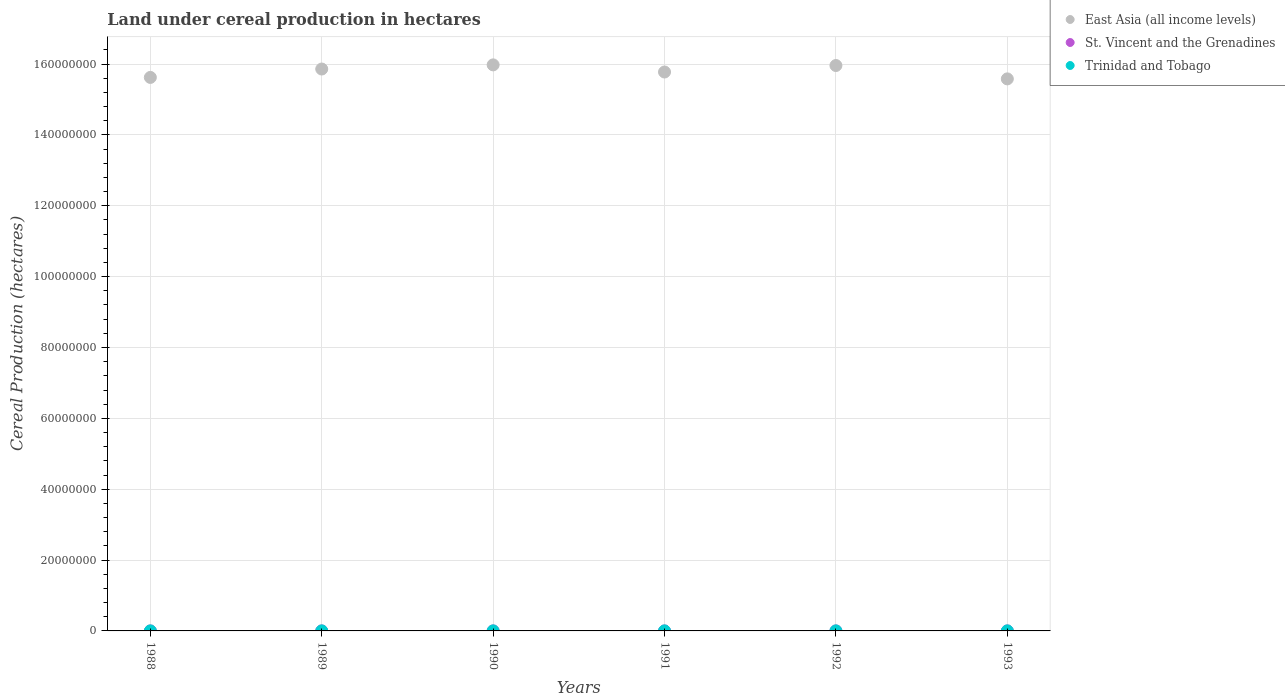Is the number of dotlines equal to the number of legend labels?
Make the answer very short. Yes. What is the land under cereal production in East Asia (all income levels) in 1991?
Offer a very short reply. 1.58e+08. Across all years, what is the maximum land under cereal production in East Asia (all income levels)?
Ensure brevity in your answer.  1.60e+08. Across all years, what is the minimum land under cereal production in St. Vincent and the Grenadines?
Your response must be concise. 505. In which year was the land under cereal production in East Asia (all income levels) minimum?
Provide a short and direct response. 1993. What is the total land under cereal production in St. Vincent and the Grenadines in the graph?
Offer a terse response. 3898. What is the difference between the land under cereal production in Trinidad and Tobago in 1991 and that in 1993?
Offer a terse response. -545. What is the difference between the land under cereal production in St. Vincent and the Grenadines in 1993 and the land under cereal production in East Asia (all income levels) in 1989?
Keep it short and to the point. -1.59e+08. What is the average land under cereal production in East Asia (all income levels) per year?
Provide a succinct answer. 1.58e+08. In the year 1993, what is the difference between the land under cereal production in Trinidad and Tobago and land under cereal production in St. Vincent and the Grenadines?
Ensure brevity in your answer.  5739. What is the ratio of the land under cereal production in Trinidad and Tobago in 1989 to that in 1992?
Give a very brief answer. 0.82. Is the land under cereal production in East Asia (all income levels) in 1988 less than that in 1993?
Offer a very short reply. No. Is the difference between the land under cereal production in Trinidad and Tobago in 1989 and 1992 greater than the difference between the land under cereal production in St. Vincent and the Grenadines in 1989 and 1992?
Provide a succinct answer. No. What is the difference between the highest and the second highest land under cereal production in East Asia (all income levels)?
Your response must be concise. 1.80e+05. What is the difference between the highest and the lowest land under cereal production in Trinidad and Tobago?
Your answer should be compact. 3250. Is the land under cereal production in St. Vincent and the Grenadines strictly greater than the land under cereal production in Trinidad and Tobago over the years?
Offer a very short reply. No. Is the land under cereal production in St. Vincent and the Grenadines strictly less than the land under cereal production in East Asia (all income levels) over the years?
Provide a short and direct response. Yes. How many years are there in the graph?
Ensure brevity in your answer.  6. Are the values on the major ticks of Y-axis written in scientific E-notation?
Keep it short and to the point. No. Does the graph contain grids?
Give a very brief answer. Yes. Where does the legend appear in the graph?
Give a very brief answer. Top right. How many legend labels are there?
Give a very brief answer. 3. What is the title of the graph?
Ensure brevity in your answer.  Land under cereal production in hectares. Does "Vietnam" appear as one of the legend labels in the graph?
Provide a succinct answer. No. What is the label or title of the X-axis?
Keep it short and to the point. Years. What is the label or title of the Y-axis?
Keep it short and to the point. Cereal Production (hectares). What is the Cereal Production (hectares) in East Asia (all income levels) in 1988?
Your response must be concise. 1.56e+08. What is the Cereal Production (hectares) of St. Vincent and the Grenadines in 1988?
Make the answer very short. 505. What is the Cereal Production (hectares) of Trinidad and Tobago in 1988?
Your answer should be very brief. 3850. What is the Cereal Production (hectares) of East Asia (all income levels) in 1989?
Your response must be concise. 1.59e+08. What is the Cereal Production (hectares) in St. Vincent and the Grenadines in 1989?
Your answer should be very brief. 605. What is the Cereal Production (hectares) of Trinidad and Tobago in 1989?
Ensure brevity in your answer.  5850. What is the Cereal Production (hectares) of East Asia (all income levels) in 1990?
Offer a very short reply. 1.60e+08. What is the Cereal Production (hectares) in St. Vincent and the Grenadines in 1990?
Give a very brief answer. 704. What is the Cereal Production (hectares) in Trinidad and Tobago in 1990?
Give a very brief answer. 5085. What is the Cereal Production (hectares) in East Asia (all income levels) in 1991?
Your response must be concise. 1.58e+08. What is the Cereal Production (hectares) in St. Vincent and the Grenadines in 1991?
Your answer should be very brief. 600. What is the Cereal Production (hectares) of Trinidad and Tobago in 1991?
Provide a succinct answer. 5955. What is the Cereal Production (hectares) of East Asia (all income levels) in 1992?
Offer a terse response. 1.60e+08. What is the Cereal Production (hectares) of St. Vincent and the Grenadines in 1992?
Provide a short and direct response. 723. What is the Cereal Production (hectares) in Trinidad and Tobago in 1992?
Offer a very short reply. 7100. What is the Cereal Production (hectares) of East Asia (all income levels) in 1993?
Your answer should be very brief. 1.56e+08. What is the Cereal Production (hectares) in St. Vincent and the Grenadines in 1993?
Your response must be concise. 761. What is the Cereal Production (hectares) of Trinidad and Tobago in 1993?
Offer a terse response. 6500. Across all years, what is the maximum Cereal Production (hectares) of East Asia (all income levels)?
Make the answer very short. 1.60e+08. Across all years, what is the maximum Cereal Production (hectares) in St. Vincent and the Grenadines?
Make the answer very short. 761. Across all years, what is the maximum Cereal Production (hectares) of Trinidad and Tobago?
Offer a terse response. 7100. Across all years, what is the minimum Cereal Production (hectares) of East Asia (all income levels)?
Your answer should be compact. 1.56e+08. Across all years, what is the minimum Cereal Production (hectares) in St. Vincent and the Grenadines?
Give a very brief answer. 505. Across all years, what is the minimum Cereal Production (hectares) in Trinidad and Tobago?
Give a very brief answer. 3850. What is the total Cereal Production (hectares) in East Asia (all income levels) in the graph?
Make the answer very short. 9.48e+08. What is the total Cereal Production (hectares) in St. Vincent and the Grenadines in the graph?
Offer a very short reply. 3898. What is the total Cereal Production (hectares) of Trinidad and Tobago in the graph?
Provide a succinct answer. 3.43e+04. What is the difference between the Cereal Production (hectares) in East Asia (all income levels) in 1988 and that in 1989?
Make the answer very short. -2.37e+06. What is the difference between the Cereal Production (hectares) of St. Vincent and the Grenadines in 1988 and that in 1989?
Make the answer very short. -100. What is the difference between the Cereal Production (hectares) of Trinidad and Tobago in 1988 and that in 1989?
Keep it short and to the point. -2000. What is the difference between the Cereal Production (hectares) of East Asia (all income levels) in 1988 and that in 1990?
Offer a very short reply. -3.54e+06. What is the difference between the Cereal Production (hectares) of St. Vincent and the Grenadines in 1988 and that in 1990?
Keep it short and to the point. -199. What is the difference between the Cereal Production (hectares) of Trinidad and Tobago in 1988 and that in 1990?
Give a very brief answer. -1235. What is the difference between the Cereal Production (hectares) in East Asia (all income levels) in 1988 and that in 1991?
Give a very brief answer. -1.53e+06. What is the difference between the Cereal Production (hectares) in St. Vincent and the Grenadines in 1988 and that in 1991?
Your response must be concise. -95. What is the difference between the Cereal Production (hectares) in Trinidad and Tobago in 1988 and that in 1991?
Keep it short and to the point. -2105. What is the difference between the Cereal Production (hectares) of East Asia (all income levels) in 1988 and that in 1992?
Make the answer very short. -3.36e+06. What is the difference between the Cereal Production (hectares) in St. Vincent and the Grenadines in 1988 and that in 1992?
Your answer should be very brief. -218. What is the difference between the Cereal Production (hectares) of Trinidad and Tobago in 1988 and that in 1992?
Keep it short and to the point. -3250. What is the difference between the Cereal Production (hectares) in East Asia (all income levels) in 1988 and that in 1993?
Give a very brief answer. 4.13e+05. What is the difference between the Cereal Production (hectares) in St. Vincent and the Grenadines in 1988 and that in 1993?
Your answer should be very brief. -256. What is the difference between the Cereal Production (hectares) of Trinidad and Tobago in 1988 and that in 1993?
Give a very brief answer. -2650. What is the difference between the Cereal Production (hectares) in East Asia (all income levels) in 1989 and that in 1990?
Offer a very short reply. -1.17e+06. What is the difference between the Cereal Production (hectares) of St. Vincent and the Grenadines in 1989 and that in 1990?
Your answer should be very brief. -99. What is the difference between the Cereal Production (hectares) of Trinidad and Tobago in 1989 and that in 1990?
Offer a very short reply. 765. What is the difference between the Cereal Production (hectares) in East Asia (all income levels) in 1989 and that in 1991?
Your answer should be compact. 8.42e+05. What is the difference between the Cereal Production (hectares) of Trinidad and Tobago in 1989 and that in 1991?
Keep it short and to the point. -105. What is the difference between the Cereal Production (hectares) of East Asia (all income levels) in 1989 and that in 1992?
Give a very brief answer. -9.92e+05. What is the difference between the Cereal Production (hectares) of St. Vincent and the Grenadines in 1989 and that in 1992?
Your response must be concise. -118. What is the difference between the Cereal Production (hectares) of Trinidad and Tobago in 1989 and that in 1992?
Your answer should be compact. -1250. What is the difference between the Cereal Production (hectares) of East Asia (all income levels) in 1989 and that in 1993?
Give a very brief answer. 2.78e+06. What is the difference between the Cereal Production (hectares) of St. Vincent and the Grenadines in 1989 and that in 1993?
Make the answer very short. -156. What is the difference between the Cereal Production (hectares) of Trinidad and Tobago in 1989 and that in 1993?
Keep it short and to the point. -650. What is the difference between the Cereal Production (hectares) of East Asia (all income levels) in 1990 and that in 1991?
Make the answer very short. 2.01e+06. What is the difference between the Cereal Production (hectares) of St. Vincent and the Grenadines in 1990 and that in 1991?
Provide a short and direct response. 104. What is the difference between the Cereal Production (hectares) of Trinidad and Tobago in 1990 and that in 1991?
Make the answer very short. -870. What is the difference between the Cereal Production (hectares) in East Asia (all income levels) in 1990 and that in 1992?
Ensure brevity in your answer.  1.80e+05. What is the difference between the Cereal Production (hectares) of St. Vincent and the Grenadines in 1990 and that in 1992?
Offer a terse response. -19. What is the difference between the Cereal Production (hectares) of Trinidad and Tobago in 1990 and that in 1992?
Offer a very short reply. -2015. What is the difference between the Cereal Production (hectares) of East Asia (all income levels) in 1990 and that in 1993?
Your answer should be very brief. 3.95e+06. What is the difference between the Cereal Production (hectares) of St. Vincent and the Grenadines in 1990 and that in 1993?
Give a very brief answer. -57. What is the difference between the Cereal Production (hectares) in Trinidad and Tobago in 1990 and that in 1993?
Ensure brevity in your answer.  -1415. What is the difference between the Cereal Production (hectares) of East Asia (all income levels) in 1991 and that in 1992?
Provide a short and direct response. -1.83e+06. What is the difference between the Cereal Production (hectares) in St. Vincent and the Grenadines in 1991 and that in 1992?
Your answer should be compact. -123. What is the difference between the Cereal Production (hectares) of Trinidad and Tobago in 1991 and that in 1992?
Provide a succinct answer. -1145. What is the difference between the Cereal Production (hectares) of East Asia (all income levels) in 1991 and that in 1993?
Your response must be concise. 1.94e+06. What is the difference between the Cereal Production (hectares) of St. Vincent and the Grenadines in 1991 and that in 1993?
Your answer should be compact. -161. What is the difference between the Cereal Production (hectares) of Trinidad and Tobago in 1991 and that in 1993?
Keep it short and to the point. -545. What is the difference between the Cereal Production (hectares) of East Asia (all income levels) in 1992 and that in 1993?
Provide a short and direct response. 3.77e+06. What is the difference between the Cereal Production (hectares) in St. Vincent and the Grenadines in 1992 and that in 1993?
Give a very brief answer. -38. What is the difference between the Cereal Production (hectares) of Trinidad and Tobago in 1992 and that in 1993?
Keep it short and to the point. 600. What is the difference between the Cereal Production (hectares) of East Asia (all income levels) in 1988 and the Cereal Production (hectares) of St. Vincent and the Grenadines in 1989?
Offer a terse response. 1.56e+08. What is the difference between the Cereal Production (hectares) in East Asia (all income levels) in 1988 and the Cereal Production (hectares) in Trinidad and Tobago in 1989?
Your response must be concise. 1.56e+08. What is the difference between the Cereal Production (hectares) in St. Vincent and the Grenadines in 1988 and the Cereal Production (hectares) in Trinidad and Tobago in 1989?
Offer a very short reply. -5345. What is the difference between the Cereal Production (hectares) in East Asia (all income levels) in 1988 and the Cereal Production (hectares) in St. Vincent and the Grenadines in 1990?
Your answer should be compact. 1.56e+08. What is the difference between the Cereal Production (hectares) of East Asia (all income levels) in 1988 and the Cereal Production (hectares) of Trinidad and Tobago in 1990?
Your answer should be very brief. 1.56e+08. What is the difference between the Cereal Production (hectares) in St. Vincent and the Grenadines in 1988 and the Cereal Production (hectares) in Trinidad and Tobago in 1990?
Your answer should be very brief. -4580. What is the difference between the Cereal Production (hectares) of East Asia (all income levels) in 1988 and the Cereal Production (hectares) of St. Vincent and the Grenadines in 1991?
Your answer should be very brief. 1.56e+08. What is the difference between the Cereal Production (hectares) in East Asia (all income levels) in 1988 and the Cereal Production (hectares) in Trinidad and Tobago in 1991?
Offer a very short reply. 1.56e+08. What is the difference between the Cereal Production (hectares) of St. Vincent and the Grenadines in 1988 and the Cereal Production (hectares) of Trinidad and Tobago in 1991?
Your answer should be compact. -5450. What is the difference between the Cereal Production (hectares) in East Asia (all income levels) in 1988 and the Cereal Production (hectares) in St. Vincent and the Grenadines in 1992?
Give a very brief answer. 1.56e+08. What is the difference between the Cereal Production (hectares) of East Asia (all income levels) in 1988 and the Cereal Production (hectares) of Trinidad and Tobago in 1992?
Keep it short and to the point. 1.56e+08. What is the difference between the Cereal Production (hectares) in St. Vincent and the Grenadines in 1988 and the Cereal Production (hectares) in Trinidad and Tobago in 1992?
Make the answer very short. -6595. What is the difference between the Cereal Production (hectares) in East Asia (all income levels) in 1988 and the Cereal Production (hectares) in St. Vincent and the Grenadines in 1993?
Offer a terse response. 1.56e+08. What is the difference between the Cereal Production (hectares) of East Asia (all income levels) in 1988 and the Cereal Production (hectares) of Trinidad and Tobago in 1993?
Make the answer very short. 1.56e+08. What is the difference between the Cereal Production (hectares) of St. Vincent and the Grenadines in 1988 and the Cereal Production (hectares) of Trinidad and Tobago in 1993?
Give a very brief answer. -5995. What is the difference between the Cereal Production (hectares) of East Asia (all income levels) in 1989 and the Cereal Production (hectares) of St. Vincent and the Grenadines in 1990?
Your answer should be very brief. 1.59e+08. What is the difference between the Cereal Production (hectares) of East Asia (all income levels) in 1989 and the Cereal Production (hectares) of Trinidad and Tobago in 1990?
Ensure brevity in your answer.  1.59e+08. What is the difference between the Cereal Production (hectares) in St. Vincent and the Grenadines in 1989 and the Cereal Production (hectares) in Trinidad and Tobago in 1990?
Give a very brief answer. -4480. What is the difference between the Cereal Production (hectares) of East Asia (all income levels) in 1989 and the Cereal Production (hectares) of St. Vincent and the Grenadines in 1991?
Your response must be concise. 1.59e+08. What is the difference between the Cereal Production (hectares) in East Asia (all income levels) in 1989 and the Cereal Production (hectares) in Trinidad and Tobago in 1991?
Provide a short and direct response. 1.59e+08. What is the difference between the Cereal Production (hectares) of St. Vincent and the Grenadines in 1989 and the Cereal Production (hectares) of Trinidad and Tobago in 1991?
Keep it short and to the point. -5350. What is the difference between the Cereal Production (hectares) in East Asia (all income levels) in 1989 and the Cereal Production (hectares) in St. Vincent and the Grenadines in 1992?
Provide a succinct answer. 1.59e+08. What is the difference between the Cereal Production (hectares) of East Asia (all income levels) in 1989 and the Cereal Production (hectares) of Trinidad and Tobago in 1992?
Provide a short and direct response. 1.59e+08. What is the difference between the Cereal Production (hectares) in St. Vincent and the Grenadines in 1989 and the Cereal Production (hectares) in Trinidad and Tobago in 1992?
Provide a succinct answer. -6495. What is the difference between the Cereal Production (hectares) in East Asia (all income levels) in 1989 and the Cereal Production (hectares) in St. Vincent and the Grenadines in 1993?
Offer a very short reply. 1.59e+08. What is the difference between the Cereal Production (hectares) in East Asia (all income levels) in 1989 and the Cereal Production (hectares) in Trinidad and Tobago in 1993?
Keep it short and to the point. 1.59e+08. What is the difference between the Cereal Production (hectares) of St. Vincent and the Grenadines in 1989 and the Cereal Production (hectares) of Trinidad and Tobago in 1993?
Give a very brief answer. -5895. What is the difference between the Cereal Production (hectares) of East Asia (all income levels) in 1990 and the Cereal Production (hectares) of St. Vincent and the Grenadines in 1991?
Offer a very short reply. 1.60e+08. What is the difference between the Cereal Production (hectares) in East Asia (all income levels) in 1990 and the Cereal Production (hectares) in Trinidad and Tobago in 1991?
Your answer should be compact. 1.60e+08. What is the difference between the Cereal Production (hectares) of St. Vincent and the Grenadines in 1990 and the Cereal Production (hectares) of Trinidad and Tobago in 1991?
Keep it short and to the point. -5251. What is the difference between the Cereal Production (hectares) in East Asia (all income levels) in 1990 and the Cereal Production (hectares) in St. Vincent and the Grenadines in 1992?
Keep it short and to the point. 1.60e+08. What is the difference between the Cereal Production (hectares) of East Asia (all income levels) in 1990 and the Cereal Production (hectares) of Trinidad and Tobago in 1992?
Provide a short and direct response. 1.60e+08. What is the difference between the Cereal Production (hectares) of St. Vincent and the Grenadines in 1990 and the Cereal Production (hectares) of Trinidad and Tobago in 1992?
Your answer should be compact. -6396. What is the difference between the Cereal Production (hectares) of East Asia (all income levels) in 1990 and the Cereal Production (hectares) of St. Vincent and the Grenadines in 1993?
Give a very brief answer. 1.60e+08. What is the difference between the Cereal Production (hectares) of East Asia (all income levels) in 1990 and the Cereal Production (hectares) of Trinidad and Tobago in 1993?
Offer a terse response. 1.60e+08. What is the difference between the Cereal Production (hectares) in St. Vincent and the Grenadines in 1990 and the Cereal Production (hectares) in Trinidad and Tobago in 1993?
Give a very brief answer. -5796. What is the difference between the Cereal Production (hectares) in East Asia (all income levels) in 1991 and the Cereal Production (hectares) in St. Vincent and the Grenadines in 1992?
Offer a terse response. 1.58e+08. What is the difference between the Cereal Production (hectares) in East Asia (all income levels) in 1991 and the Cereal Production (hectares) in Trinidad and Tobago in 1992?
Make the answer very short. 1.58e+08. What is the difference between the Cereal Production (hectares) in St. Vincent and the Grenadines in 1991 and the Cereal Production (hectares) in Trinidad and Tobago in 1992?
Provide a short and direct response. -6500. What is the difference between the Cereal Production (hectares) of East Asia (all income levels) in 1991 and the Cereal Production (hectares) of St. Vincent and the Grenadines in 1993?
Make the answer very short. 1.58e+08. What is the difference between the Cereal Production (hectares) of East Asia (all income levels) in 1991 and the Cereal Production (hectares) of Trinidad and Tobago in 1993?
Provide a short and direct response. 1.58e+08. What is the difference between the Cereal Production (hectares) of St. Vincent and the Grenadines in 1991 and the Cereal Production (hectares) of Trinidad and Tobago in 1993?
Your answer should be compact. -5900. What is the difference between the Cereal Production (hectares) of East Asia (all income levels) in 1992 and the Cereal Production (hectares) of St. Vincent and the Grenadines in 1993?
Offer a terse response. 1.60e+08. What is the difference between the Cereal Production (hectares) in East Asia (all income levels) in 1992 and the Cereal Production (hectares) in Trinidad and Tobago in 1993?
Make the answer very short. 1.60e+08. What is the difference between the Cereal Production (hectares) in St. Vincent and the Grenadines in 1992 and the Cereal Production (hectares) in Trinidad and Tobago in 1993?
Offer a very short reply. -5777. What is the average Cereal Production (hectares) of East Asia (all income levels) per year?
Your answer should be compact. 1.58e+08. What is the average Cereal Production (hectares) of St. Vincent and the Grenadines per year?
Make the answer very short. 649.67. What is the average Cereal Production (hectares) of Trinidad and Tobago per year?
Offer a terse response. 5723.33. In the year 1988, what is the difference between the Cereal Production (hectares) of East Asia (all income levels) and Cereal Production (hectares) of St. Vincent and the Grenadines?
Keep it short and to the point. 1.56e+08. In the year 1988, what is the difference between the Cereal Production (hectares) in East Asia (all income levels) and Cereal Production (hectares) in Trinidad and Tobago?
Provide a succinct answer. 1.56e+08. In the year 1988, what is the difference between the Cereal Production (hectares) of St. Vincent and the Grenadines and Cereal Production (hectares) of Trinidad and Tobago?
Your response must be concise. -3345. In the year 1989, what is the difference between the Cereal Production (hectares) in East Asia (all income levels) and Cereal Production (hectares) in St. Vincent and the Grenadines?
Provide a short and direct response. 1.59e+08. In the year 1989, what is the difference between the Cereal Production (hectares) of East Asia (all income levels) and Cereal Production (hectares) of Trinidad and Tobago?
Your answer should be compact. 1.59e+08. In the year 1989, what is the difference between the Cereal Production (hectares) in St. Vincent and the Grenadines and Cereal Production (hectares) in Trinidad and Tobago?
Give a very brief answer. -5245. In the year 1990, what is the difference between the Cereal Production (hectares) in East Asia (all income levels) and Cereal Production (hectares) in St. Vincent and the Grenadines?
Offer a terse response. 1.60e+08. In the year 1990, what is the difference between the Cereal Production (hectares) of East Asia (all income levels) and Cereal Production (hectares) of Trinidad and Tobago?
Your answer should be very brief. 1.60e+08. In the year 1990, what is the difference between the Cereal Production (hectares) of St. Vincent and the Grenadines and Cereal Production (hectares) of Trinidad and Tobago?
Your response must be concise. -4381. In the year 1991, what is the difference between the Cereal Production (hectares) in East Asia (all income levels) and Cereal Production (hectares) in St. Vincent and the Grenadines?
Your answer should be very brief. 1.58e+08. In the year 1991, what is the difference between the Cereal Production (hectares) of East Asia (all income levels) and Cereal Production (hectares) of Trinidad and Tobago?
Offer a terse response. 1.58e+08. In the year 1991, what is the difference between the Cereal Production (hectares) of St. Vincent and the Grenadines and Cereal Production (hectares) of Trinidad and Tobago?
Offer a terse response. -5355. In the year 1992, what is the difference between the Cereal Production (hectares) of East Asia (all income levels) and Cereal Production (hectares) of St. Vincent and the Grenadines?
Make the answer very short. 1.60e+08. In the year 1992, what is the difference between the Cereal Production (hectares) of East Asia (all income levels) and Cereal Production (hectares) of Trinidad and Tobago?
Provide a short and direct response. 1.60e+08. In the year 1992, what is the difference between the Cereal Production (hectares) of St. Vincent and the Grenadines and Cereal Production (hectares) of Trinidad and Tobago?
Keep it short and to the point. -6377. In the year 1993, what is the difference between the Cereal Production (hectares) of East Asia (all income levels) and Cereal Production (hectares) of St. Vincent and the Grenadines?
Keep it short and to the point. 1.56e+08. In the year 1993, what is the difference between the Cereal Production (hectares) of East Asia (all income levels) and Cereal Production (hectares) of Trinidad and Tobago?
Provide a short and direct response. 1.56e+08. In the year 1993, what is the difference between the Cereal Production (hectares) in St. Vincent and the Grenadines and Cereal Production (hectares) in Trinidad and Tobago?
Ensure brevity in your answer.  -5739. What is the ratio of the Cereal Production (hectares) of East Asia (all income levels) in 1988 to that in 1989?
Provide a short and direct response. 0.99. What is the ratio of the Cereal Production (hectares) of St. Vincent and the Grenadines in 1988 to that in 1989?
Give a very brief answer. 0.83. What is the ratio of the Cereal Production (hectares) in Trinidad and Tobago in 1988 to that in 1989?
Make the answer very short. 0.66. What is the ratio of the Cereal Production (hectares) in East Asia (all income levels) in 1988 to that in 1990?
Offer a very short reply. 0.98. What is the ratio of the Cereal Production (hectares) of St. Vincent and the Grenadines in 1988 to that in 1990?
Your answer should be very brief. 0.72. What is the ratio of the Cereal Production (hectares) of Trinidad and Tobago in 1988 to that in 1990?
Make the answer very short. 0.76. What is the ratio of the Cereal Production (hectares) in East Asia (all income levels) in 1988 to that in 1991?
Provide a short and direct response. 0.99. What is the ratio of the Cereal Production (hectares) of St. Vincent and the Grenadines in 1988 to that in 1991?
Make the answer very short. 0.84. What is the ratio of the Cereal Production (hectares) in Trinidad and Tobago in 1988 to that in 1991?
Your response must be concise. 0.65. What is the ratio of the Cereal Production (hectares) of East Asia (all income levels) in 1988 to that in 1992?
Keep it short and to the point. 0.98. What is the ratio of the Cereal Production (hectares) in St. Vincent and the Grenadines in 1988 to that in 1992?
Your answer should be compact. 0.7. What is the ratio of the Cereal Production (hectares) of Trinidad and Tobago in 1988 to that in 1992?
Give a very brief answer. 0.54. What is the ratio of the Cereal Production (hectares) of East Asia (all income levels) in 1988 to that in 1993?
Keep it short and to the point. 1. What is the ratio of the Cereal Production (hectares) of St. Vincent and the Grenadines in 1988 to that in 1993?
Make the answer very short. 0.66. What is the ratio of the Cereal Production (hectares) in Trinidad and Tobago in 1988 to that in 1993?
Make the answer very short. 0.59. What is the ratio of the Cereal Production (hectares) of St. Vincent and the Grenadines in 1989 to that in 1990?
Provide a succinct answer. 0.86. What is the ratio of the Cereal Production (hectares) in Trinidad and Tobago in 1989 to that in 1990?
Offer a terse response. 1.15. What is the ratio of the Cereal Production (hectares) of East Asia (all income levels) in 1989 to that in 1991?
Offer a very short reply. 1.01. What is the ratio of the Cereal Production (hectares) of St. Vincent and the Grenadines in 1989 to that in 1991?
Offer a terse response. 1.01. What is the ratio of the Cereal Production (hectares) of Trinidad and Tobago in 1989 to that in 1991?
Offer a very short reply. 0.98. What is the ratio of the Cereal Production (hectares) in St. Vincent and the Grenadines in 1989 to that in 1992?
Offer a very short reply. 0.84. What is the ratio of the Cereal Production (hectares) of Trinidad and Tobago in 1989 to that in 1992?
Offer a terse response. 0.82. What is the ratio of the Cereal Production (hectares) of East Asia (all income levels) in 1989 to that in 1993?
Provide a short and direct response. 1.02. What is the ratio of the Cereal Production (hectares) of St. Vincent and the Grenadines in 1989 to that in 1993?
Offer a terse response. 0.8. What is the ratio of the Cereal Production (hectares) of Trinidad and Tobago in 1989 to that in 1993?
Your answer should be compact. 0.9. What is the ratio of the Cereal Production (hectares) in East Asia (all income levels) in 1990 to that in 1991?
Provide a short and direct response. 1.01. What is the ratio of the Cereal Production (hectares) of St. Vincent and the Grenadines in 1990 to that in 1991?
Ensure brevity in your answer.  1.17. What is the ratio of the Cereal Production (hectares) in Trinidad and Tobago in 1990 to that in 1991?
Offer a very short reply. 0.85. What is the ratio of the Cereal Production (hectares) in St. Vincent and the Grenadines in 1990 to that in 1992?
Provide a succinct answer. 0.97. What is the ratio of the Cereal Production (hectares) in Trinidad and Tobago in 1990 to that in 1992?
Make the answer very short. 0.72. What is the ratio of the Cereal Production (hectares) in East Asia (all income levels) in 1990 to that in 1993?
Offer a very short reply. 1.03. What is the ratio of the Cereal Production (hectares) in St. Vincent and the Grenadines in 1990 to that in 1993?
Your response must be concise. 0.93. What is the ratio of the Cereal Production (hectares) of Trinidad and Tobago in 1990 to that in 1993?
Your response must be concise. 0.78. What is the ratio of the Cereal Production (hectares) of East Asia (all income levels) in 1991 to that in 1992?
Give a very brief answer. 0.99. What is the ratio of the Cereal Production (hectares) in St. Vincent and the Grenadines in 1991 to that in 1992?
Provide a short and direct response. 0.83. What is the ratio of the Cereal Production (hectares) in Trinidad and Tobago in 1991 to that in 1992?
Make the answer very short. 0.84. What is the ratio of the Cereal Production (hectares) in East Asia (all income levels) in 1991 to that in 1993?
Ensure brevity in your answer.  1.01. What is the ratio of the Cereal Production (hectares) in St. Vincent and the Grenadines in 1991 to that in 1993?
Make the answer very short. 0.79. What is the ratio of the Cereal Production (hectares) in Trinidad and Tobago in 1991 to that in 1993?
Make the answer very short. 0.92. What is the ratio of the Cereal Production (hectares) of East Asia (all income levels) in 1992 to that in 1993?
Offer a very short reply. 1.02. What is the ratio of the Cereal Production (hectares) of St. Vincent and the Grenadines in 1992 to that in 1993?
Make the answer very short. 0.95. What is the ratio of the Cereal Production (hectares) in Trinidad and Tobago in 1992 to that in 1993?
Keep it short and to the point. 1.09. What is the difference between the highest and the second highest Cereal Production (hectares) of East Asia (all income levels)?
Ensure brevity in your answer.  1.80e+05. What is the difference between the highest and the second highest Cereal Production (hectares) in St. Vincent and the Grenadines?
Make the answer very short. 38. What is the difference between the highest and the second highest Cereal Production (hectares) in Trinidad and Tobago?
Provide a short and direct response. 600. What is the difference between the highest and the lowest Cereal Production (hectares) of East Asia (all income levels)?
Offer a terse response. 3.95e+06. What is the difference between the highest and the lowest Cereal Production (hectares) of St. Vincent and the Grenadines?
Your answer should be compact. 256. What is the difference between the highest and the lowest Cereal Production (hectares) of Trinidad and Tobago?
Your answer should be very brief. 3250. 